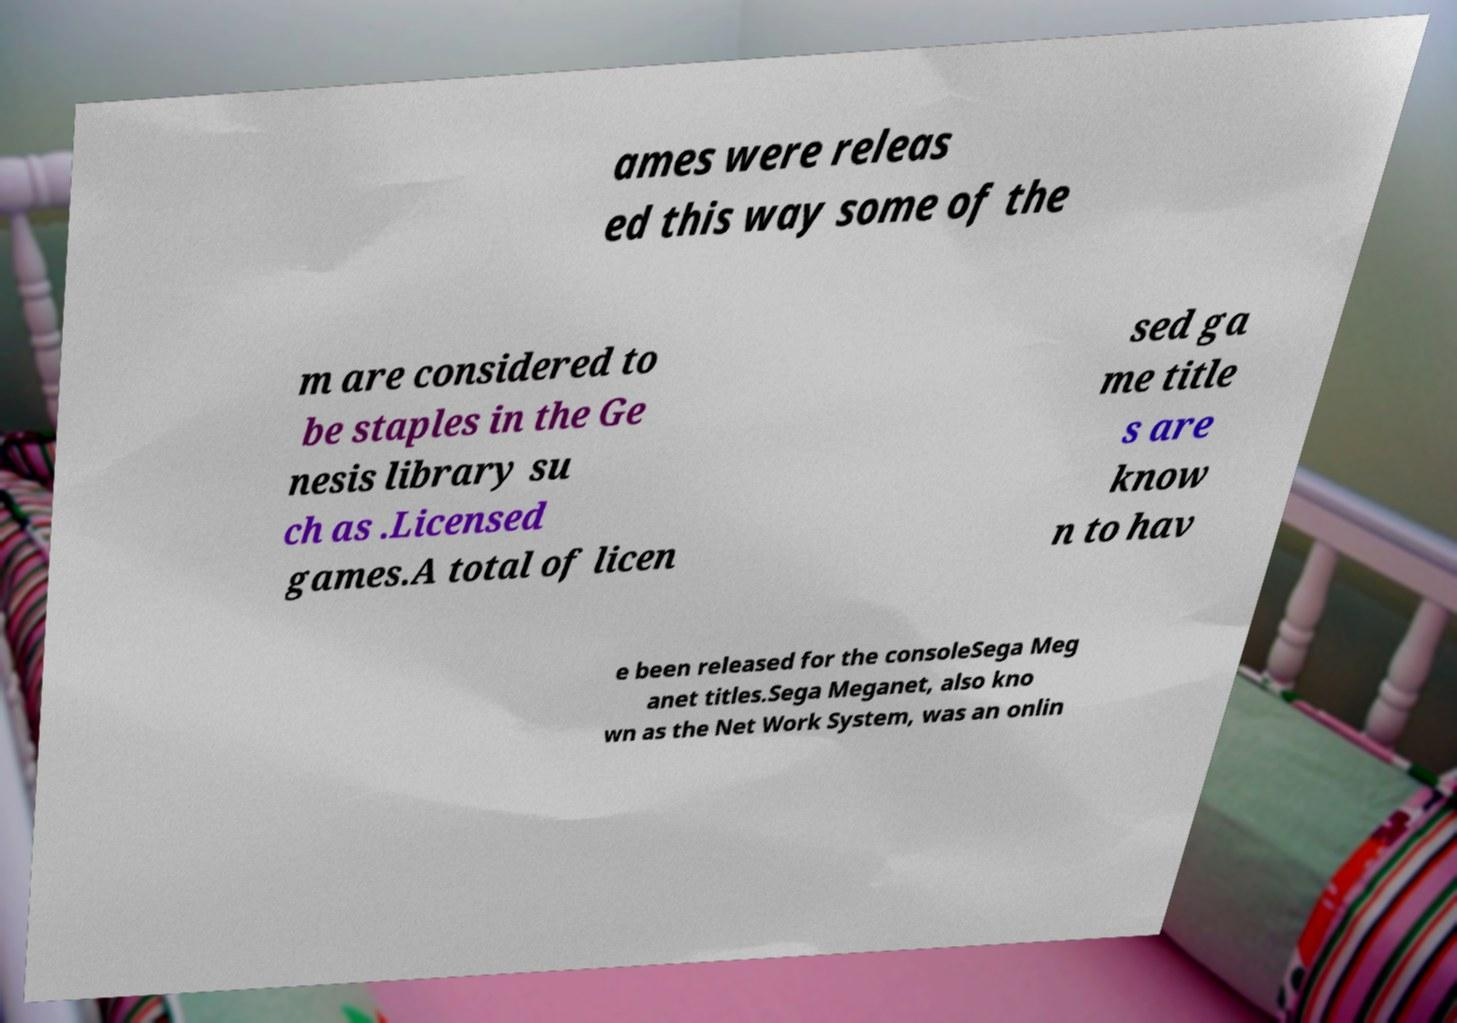Can you accurately transcribe the text from the provided image for me? ames were releas ed this way some of the m are considered to be staples in the Ge nesis library su ch as .Licensed games.A total of licen sed ga me title s are know n to hav e been released for the consoleSega Meg anet titles.Sega Meganet, also kno wn as the Net Work System, was an onlin 